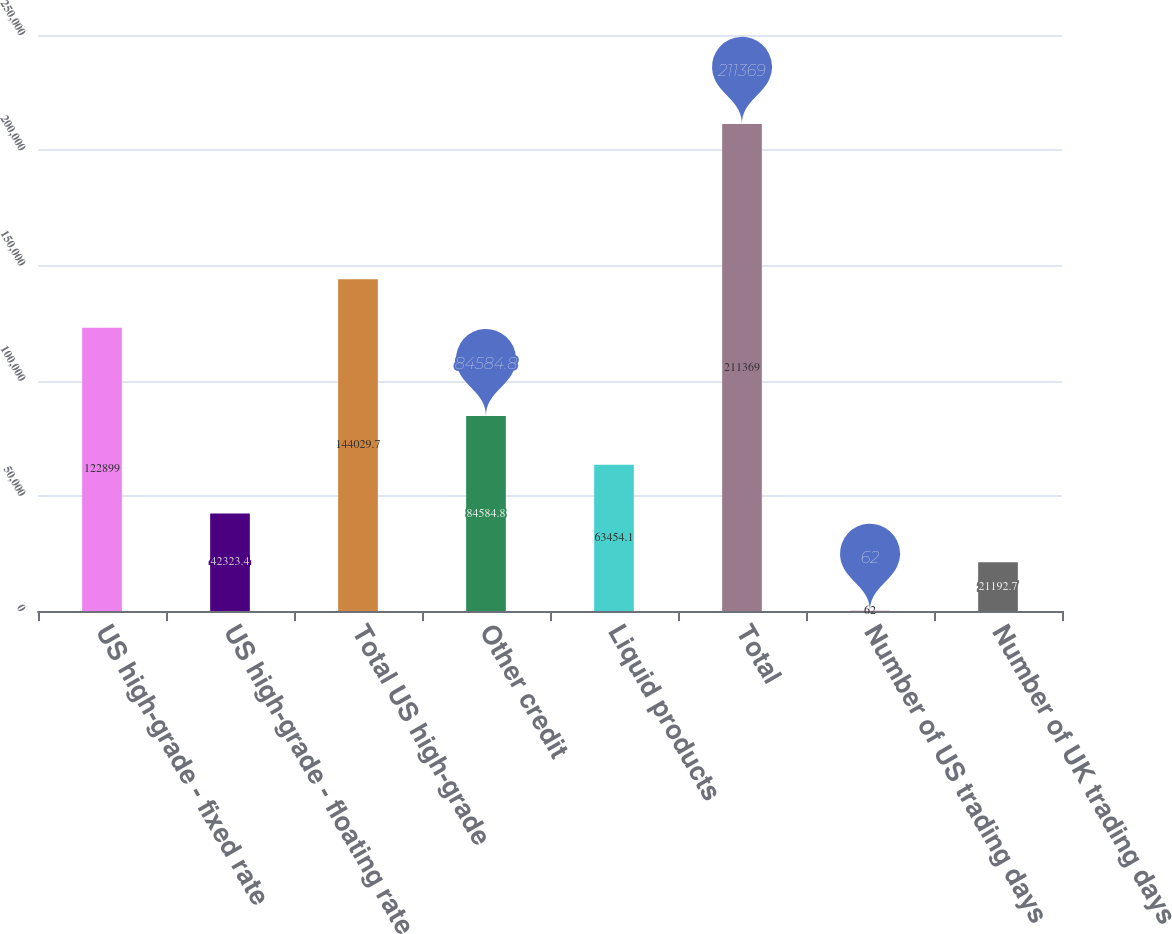<chart> <loc_0><loc_0><loc_500><loc_500><bar_chart><fcel>US high-grade - fixed rate<fcel>US high-grade - floating rate<fcel>Total US high-grade<fcel>Other credit<fcel>Liquid products<fcel>Total<fcel>Number of US trading days<fcel>Number of UK trading days<nl><fcel>122899<fcel>42323.4<fcel>144030<fcel>84584.8<fcel>63454.1<fcel>211369<fcel>62<fcel>21192.7<nl></chart> 